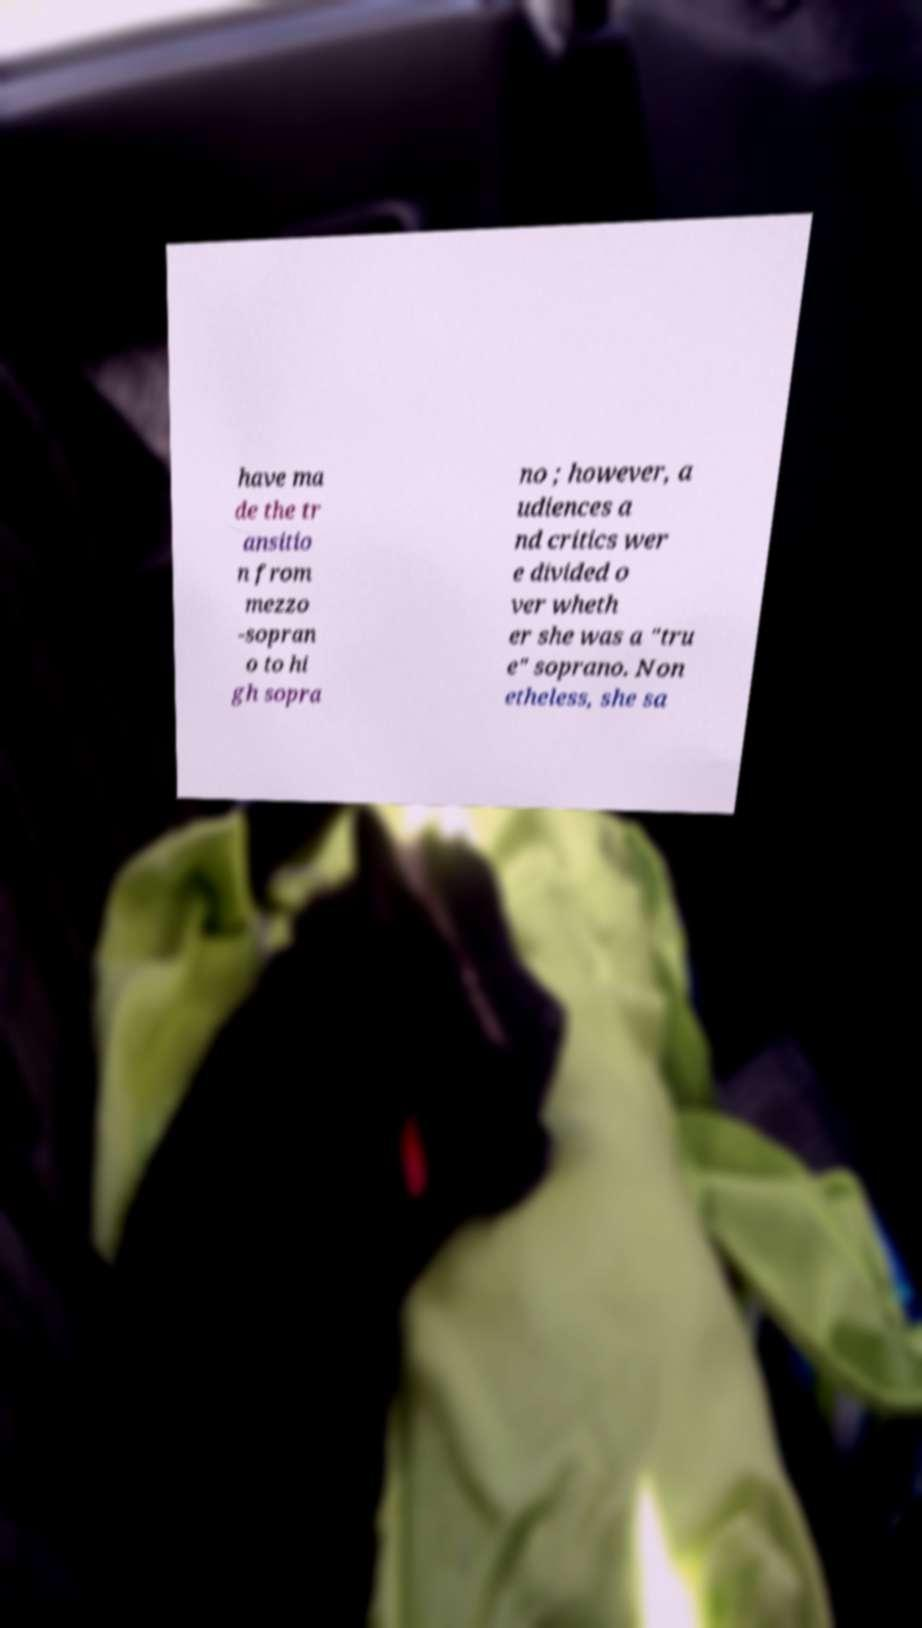Can you read and provide the text displayed in the image?This photo seems to have some interesting text. Can you extract and type it out for me? have ma de the tr ansitio n from mezzo -sopran o to hi gh sopra no ; however, a udiences a nd critics wer e divided o ver wheth er she was a "tru e" soprano. Non etheless, she sa 